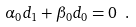Convert formula to latex. <formula><loc_0><loc_0><loc_500><loc_500>\alpha _ { 0 } d _ { 1 } + \beta _ { 0 } d _ { 0 } = 0 \ .</formula> 